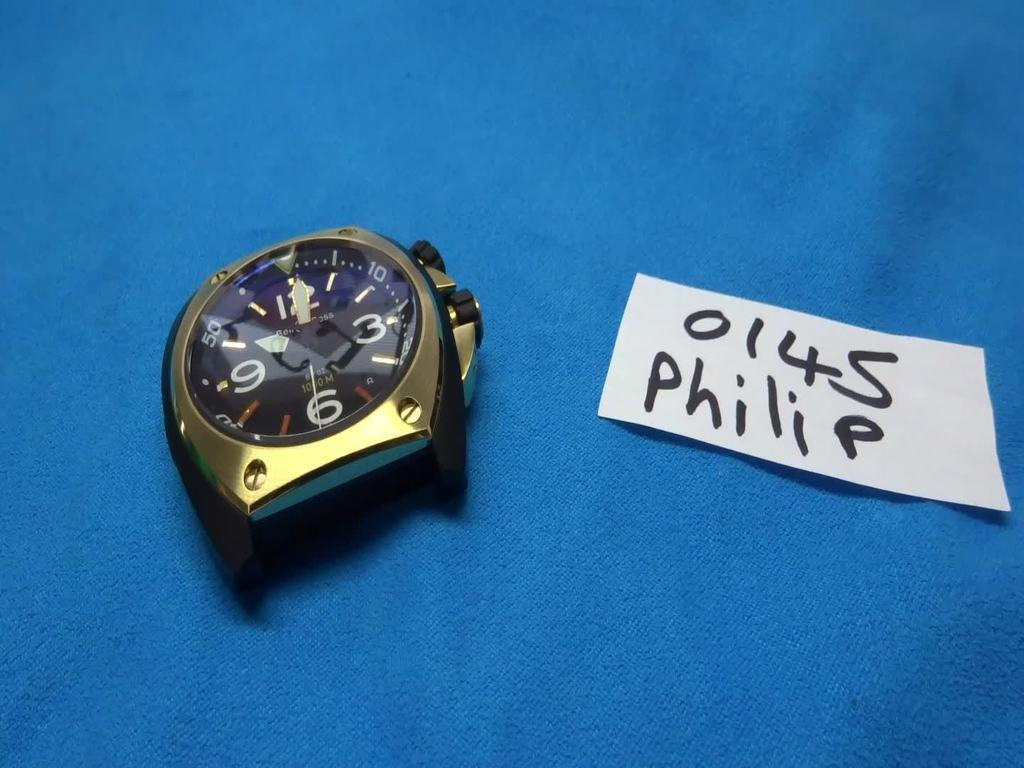<image>
Describe the image concisely. Part of a wristwatch next to a white label which says 0145 Philip. 